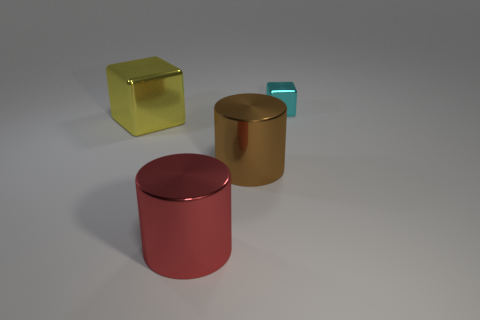Add 1 big yellow metallic blocks. How many objects exist? 5 Subtract 0 gray blocks. How many objects are left? 4 Subtract all brown cylinders. Subtract all metallic cubes. How many objects are left? 1 Add 3 brown metal cylinders. How many brown metal cylinders are left? 4 Add 2 brown shiny objects. How many brown shiny objects exist? 3 